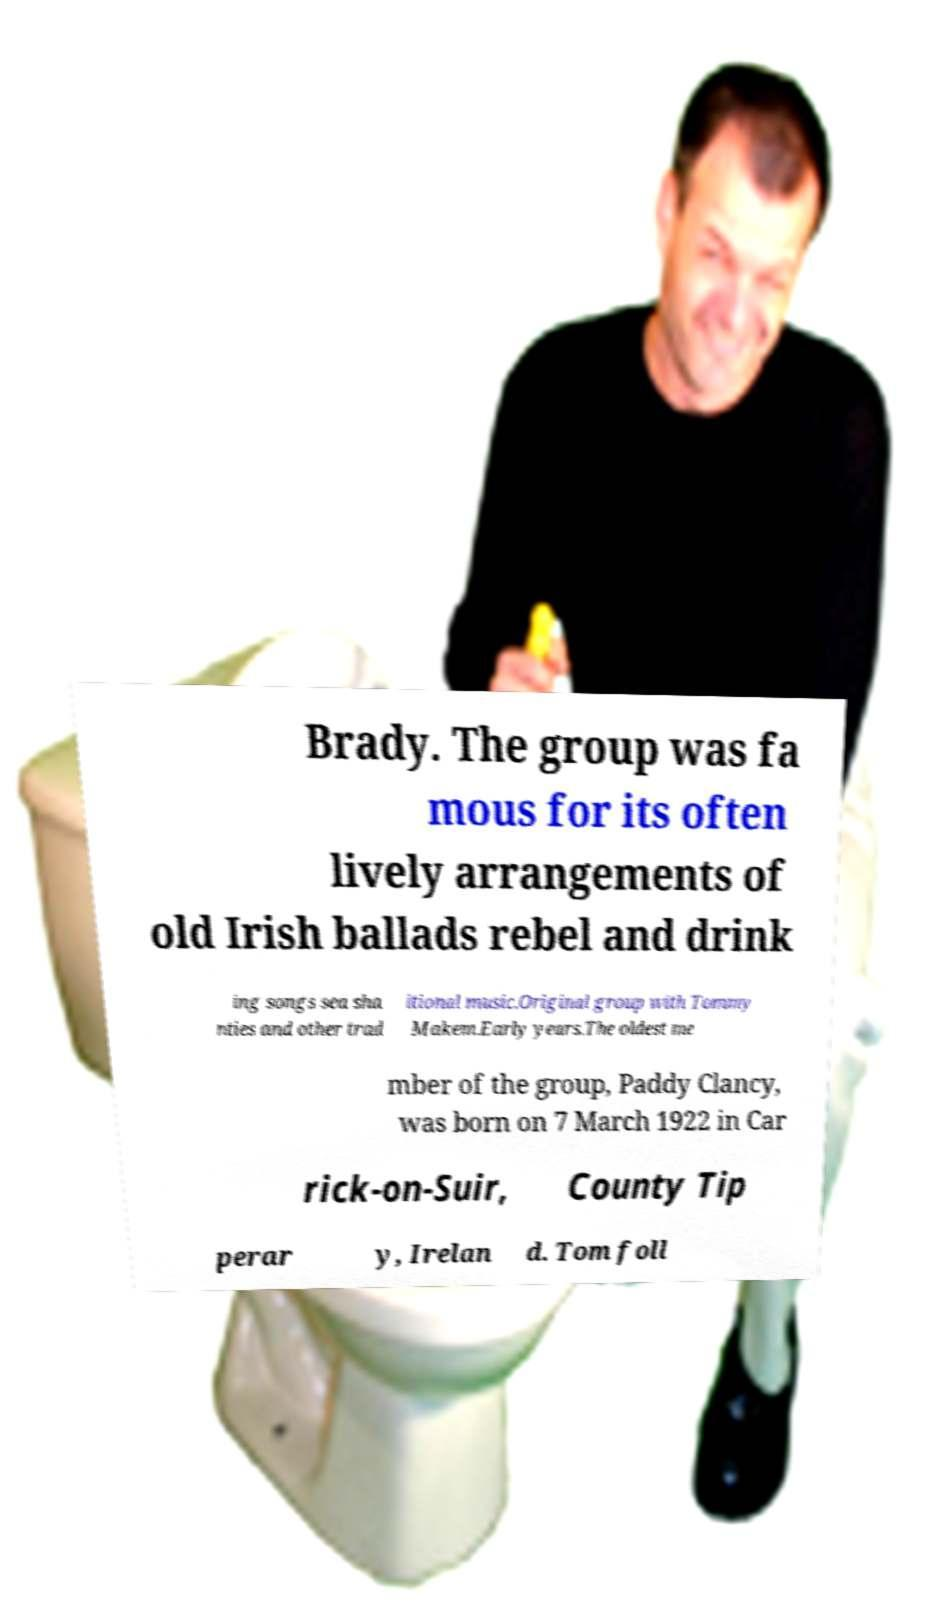What messages or text are displayed in this image? I need them in a readable, typed format. Brady. The group was fa mous for its often lively arrangements of old Irish ballads rebel and drink ing songs sea sha nties and other trad itional music.Original group with Tommy Makem.Early years.The oldest me mber of the group, Paddy Clancy, was born on 7 March 1922 in Car rick-on-Suir, County Tip perar y, Irelan d. Tom foll 